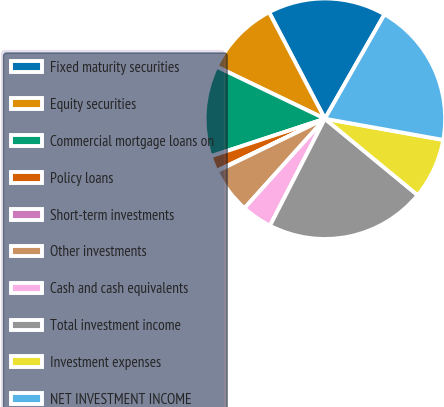Convert chart. <chart><loc_0><loc_0><loc_500><loc_500><pie_chart><fcel>Fixed maturity securities<fcel>Equity securities<fcel>Commercial mortgage loans on<fcel>Policy loans<fcel>Short-term investments<fcel>Other investments<fcel>Cash and cash equivalents<fcel>Total investment income<fcel>Investment expenses<fcel>NET INVESTMENT INCOME<nl><fcel>15.94%<fcel>10.18%<fcel>12.2%<fcel>2.09%<fcel>0.06%<fcel>6.13%<fcel>4.11%<fcel>21.58%<fcel>8.15%<fcel>19.56%<nl></chart> 